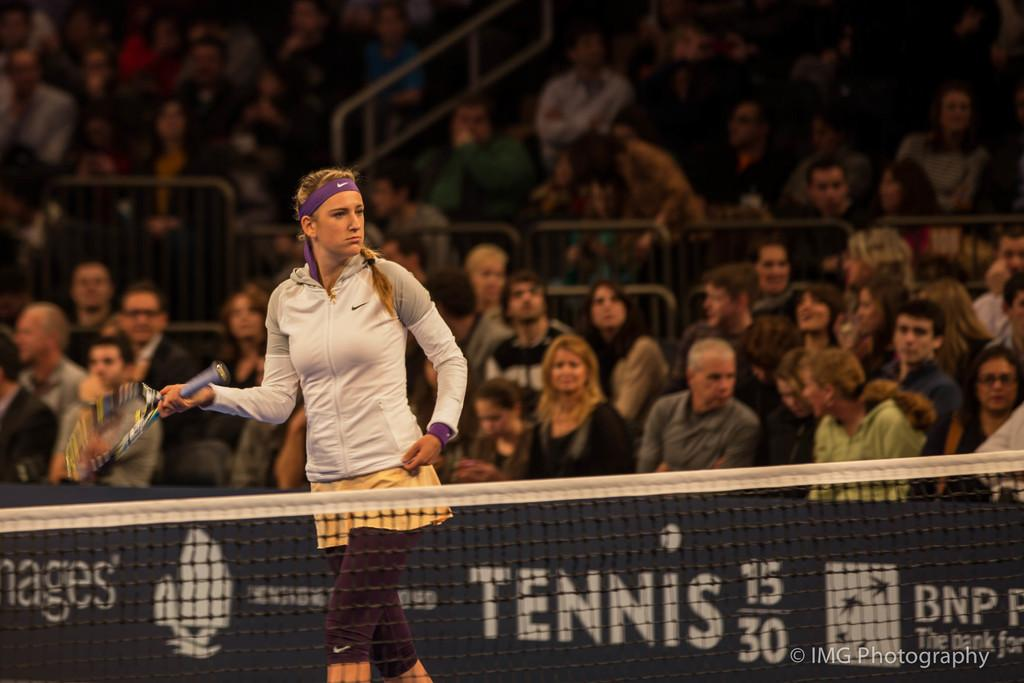What is the person in the image holding? The person is holding a bat. What can be seen in the image besides the person holding the bat? There is a net in the image. What is the position of the group of people in the image? The group of people is sitting in the background. What type of turkey can be seen in the image? There is no turkey present in the image. Can you describe the interaction between the person holding the bat and the stranger in the image? There is no stranger present in the image; only the person holding the bat and the group of people sitting in the background can be seen. 